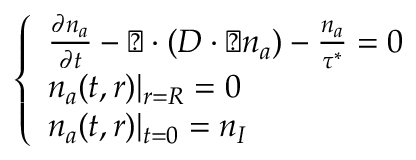<formula> <loc_0><loc_0><loc_500><loc_500>\left \{ \begin{array} { l l } { \frac { \partial n _ { a } } { \partial t } - \triangle d o w n \cdot ( D \cdot \triangle d o w n n _ { a } ) - \frac { n _ { a } } { \tau ^ { * } } = 0 } \\ { n _ { a } ( t , r ) | _ { r = R } = 0 } \\ { n _ { a } ( t , r ) | _ { t = 0 } = n _ { I } } \end{array}</formula> 